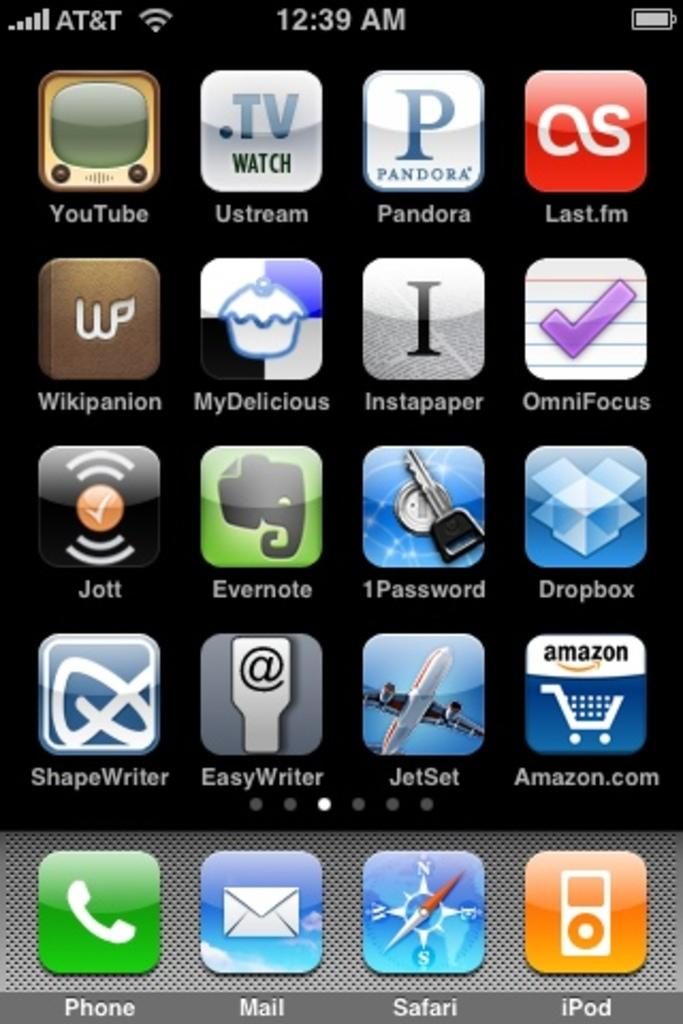<image>
Relay a brief, clear account of the picture shown. A phone screen has a selection of apps including Pandora at the top. 